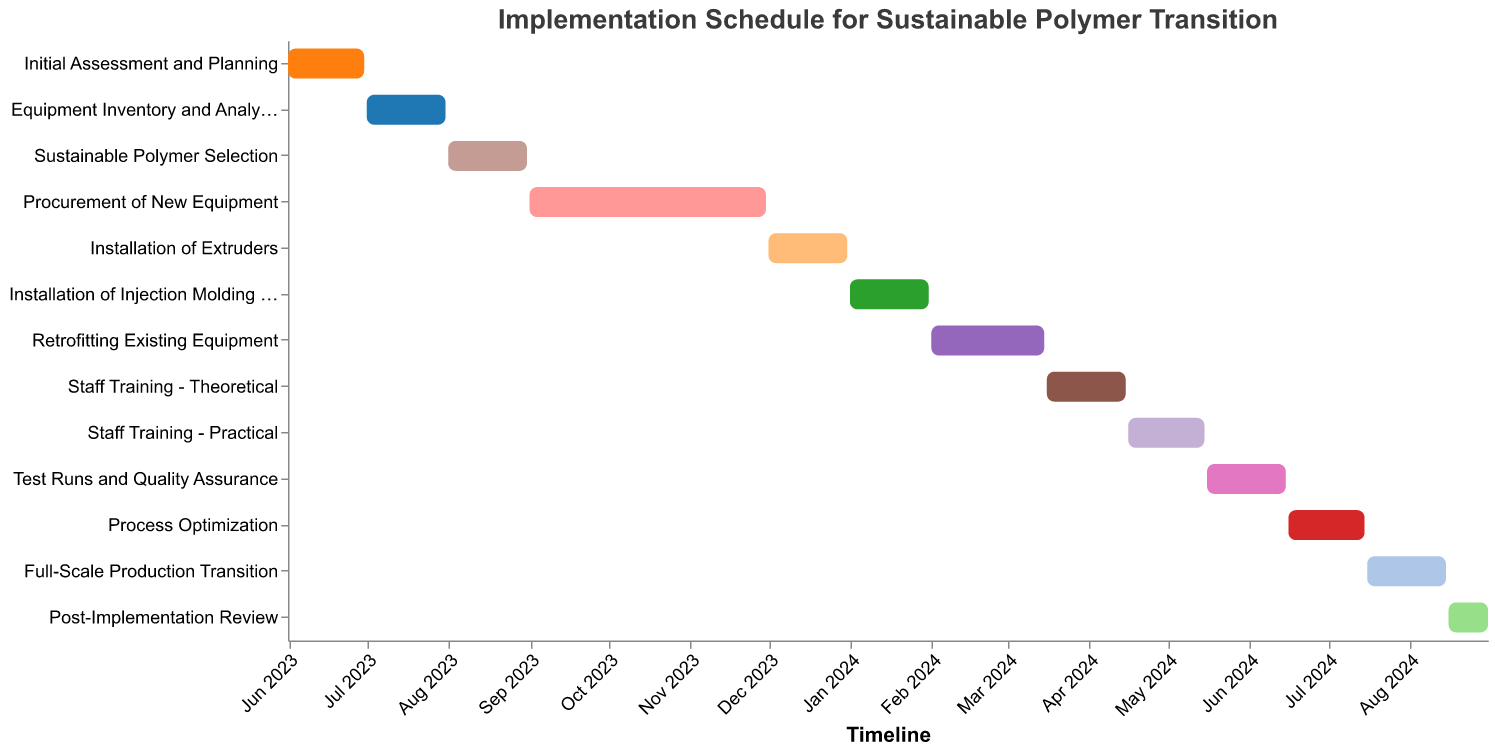What is the title of the Gantt chart? The title of the chart is displayed prominently at the top. It indicates what the timeline represents.
Answer: Implementation Schedule for Sustainable Polymer Transition How many tasks are listed in the Gantt chart? You can count the number of unique tasks along the y-axis of the chart.
Answer: 13 What is the duration of the "Procurement of New Equipment" task? By looking at the tooltip or checking the duration of the highlighted bar for this task, you can find the specific number of days.
Answer: 91 days Which task has the shortest duration, and how long does it last? By comparing the durations of each task listed in the Gantt chart, you can identify the task with the shortest bar and check its duration.
Answer: Post-Implementation Review, 16 days What are the start and end dates for "Installation of Extruders"? Examine the start and end points of the bar representing the "Installation of Extruders" task.
Answer: 2023-12-01 to 2023-12-31 What tasks occur simultaneously in February 2024? Look at the timeline for February 2024 and identify bars that overlap during this period.
Answer: Retrofitting Existing Equipment How long does the entire transition process take, from the start of "Initial Assessment and Planning" to the end of the "Post-Implementation Review"? Calculate the difference between the start date of the first task and the end date of the last task.
Answer: From 2023-06-01 to 2024-08-31, 457 days Which staff training phase comes first, theoretical or practical? Compare the start dates of "Staff Training - Theoretical" and "Staff Training - Practical".
Answer: Staff Training - Theoretical Which task starts immediately after the "Retrofitting Existing Equipment" ends? Look at the end date of "Retrofitting Existing Equipment" and check the next task's start date.
Answer: Staff Training - Theoretical What is the gap between the end of "Process Optimization" and the start of the "Full-Scale Production Transition"? Subtract the end date of "Process Optimization" from the start date of "Full-Scale Production Transition." Calculate the days in between.
Answer: 1 day 